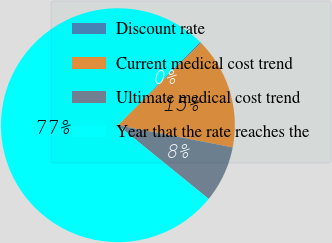<chart> <loc_0><loc_0><loc_500><loc_500><pie_chart><fcel>Discount rate<fcel>Current medical cost trend<fcel>Ultimate medical cost trend<fcel>Year that the rate reaches the<nl><fcel>0.18%<fcel>15.46%<fcel>7.82%<fcel>76.54%<nl></chart> 